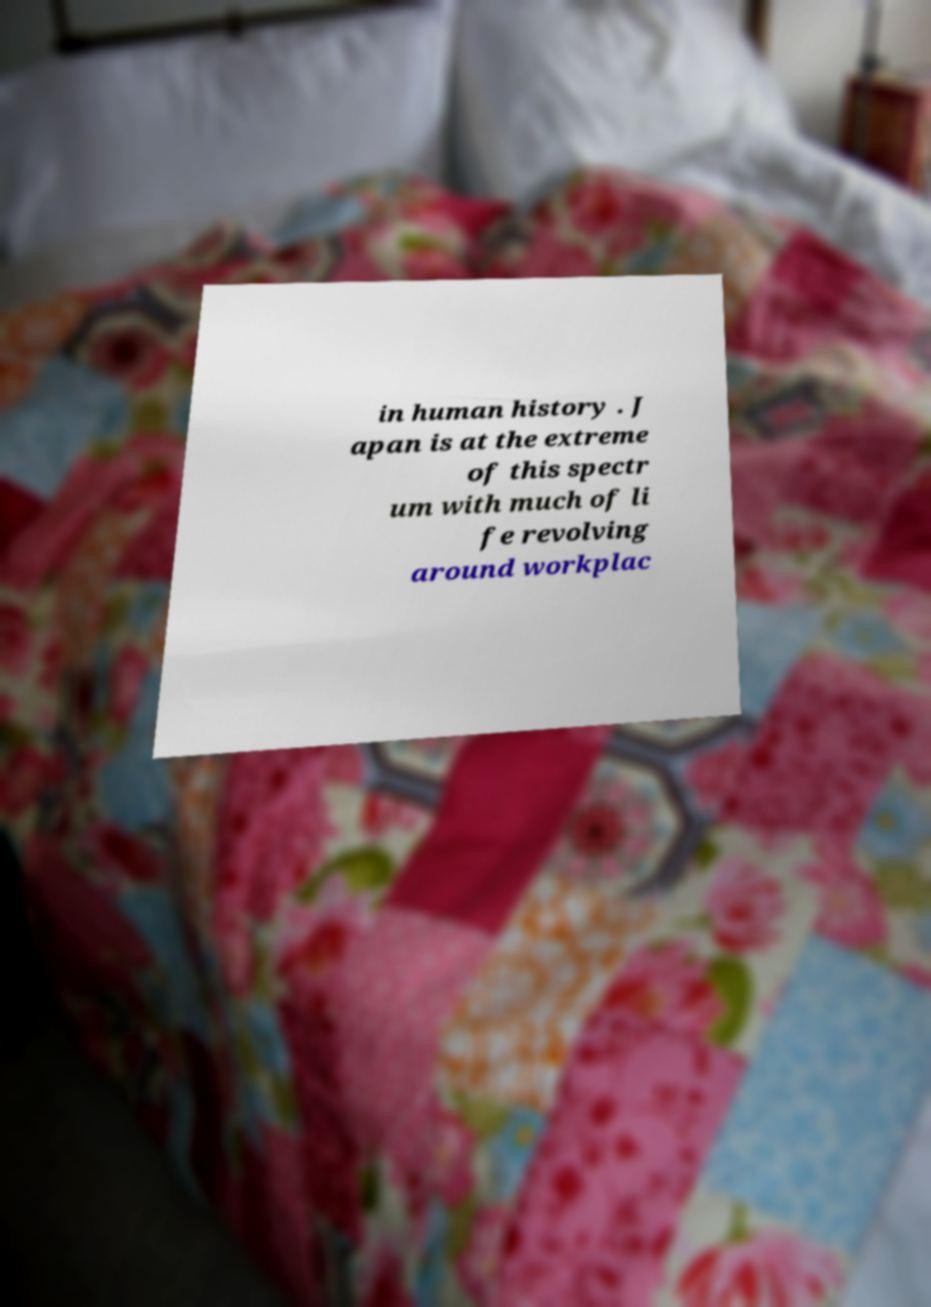Could you extract and type out the text from this image? in human history . J apan is at the extreme of this spectr um with much of li fe revolving around workplac 